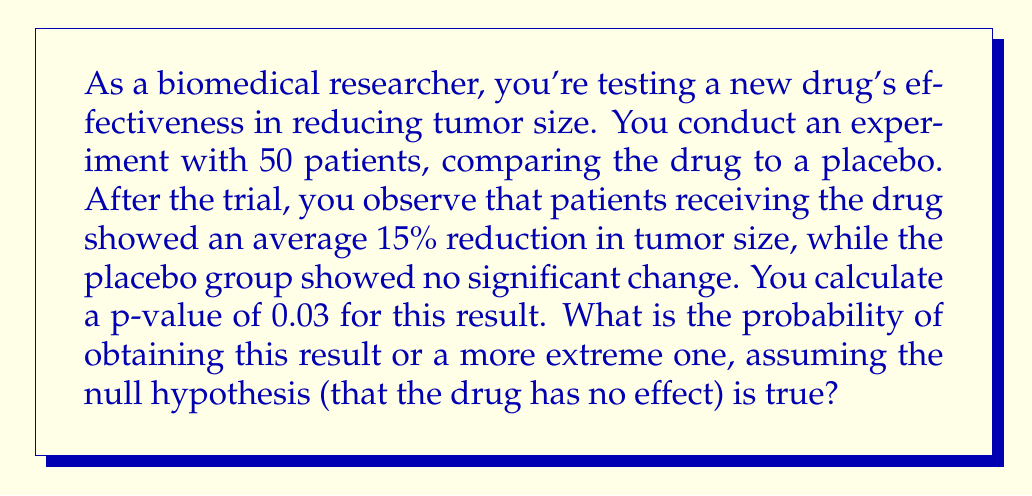Give your solution to this math problem. To interpret the statistical significance of experimental results using p-values, we need to understand what a p-value represents:

1. The p-value is the probability of obtaining results at least as extreme as the observed results, assuming that the null hypothesis is true.

2. In this case, the null hypothesis is that the drug has no effect on tumor size.

3. The calculated p-value is 0.03, or 3%.

4. This means that if the null hypothesis were true (i.e., if the drug had no effect), the probability of observing a 15% reduction in tumor size or an even more extreme result is 3%.

5. In statistical terms, we can express this as:

   $P(\text{observed result} | H_0) = 0.03$

   where $H_0$ represents the null hypothesis.

6. The p-value of 0.03 is less than the commonly used significance level of 0.05 (5%), which suggests that the result is statistically significant.

7. However, it's important to note that the p-value does not tell us the probability that the null hypothesis is true or false. It only tells us the likelihood of obtaining such results if the null hypothesis were true.
Answer: 3% 